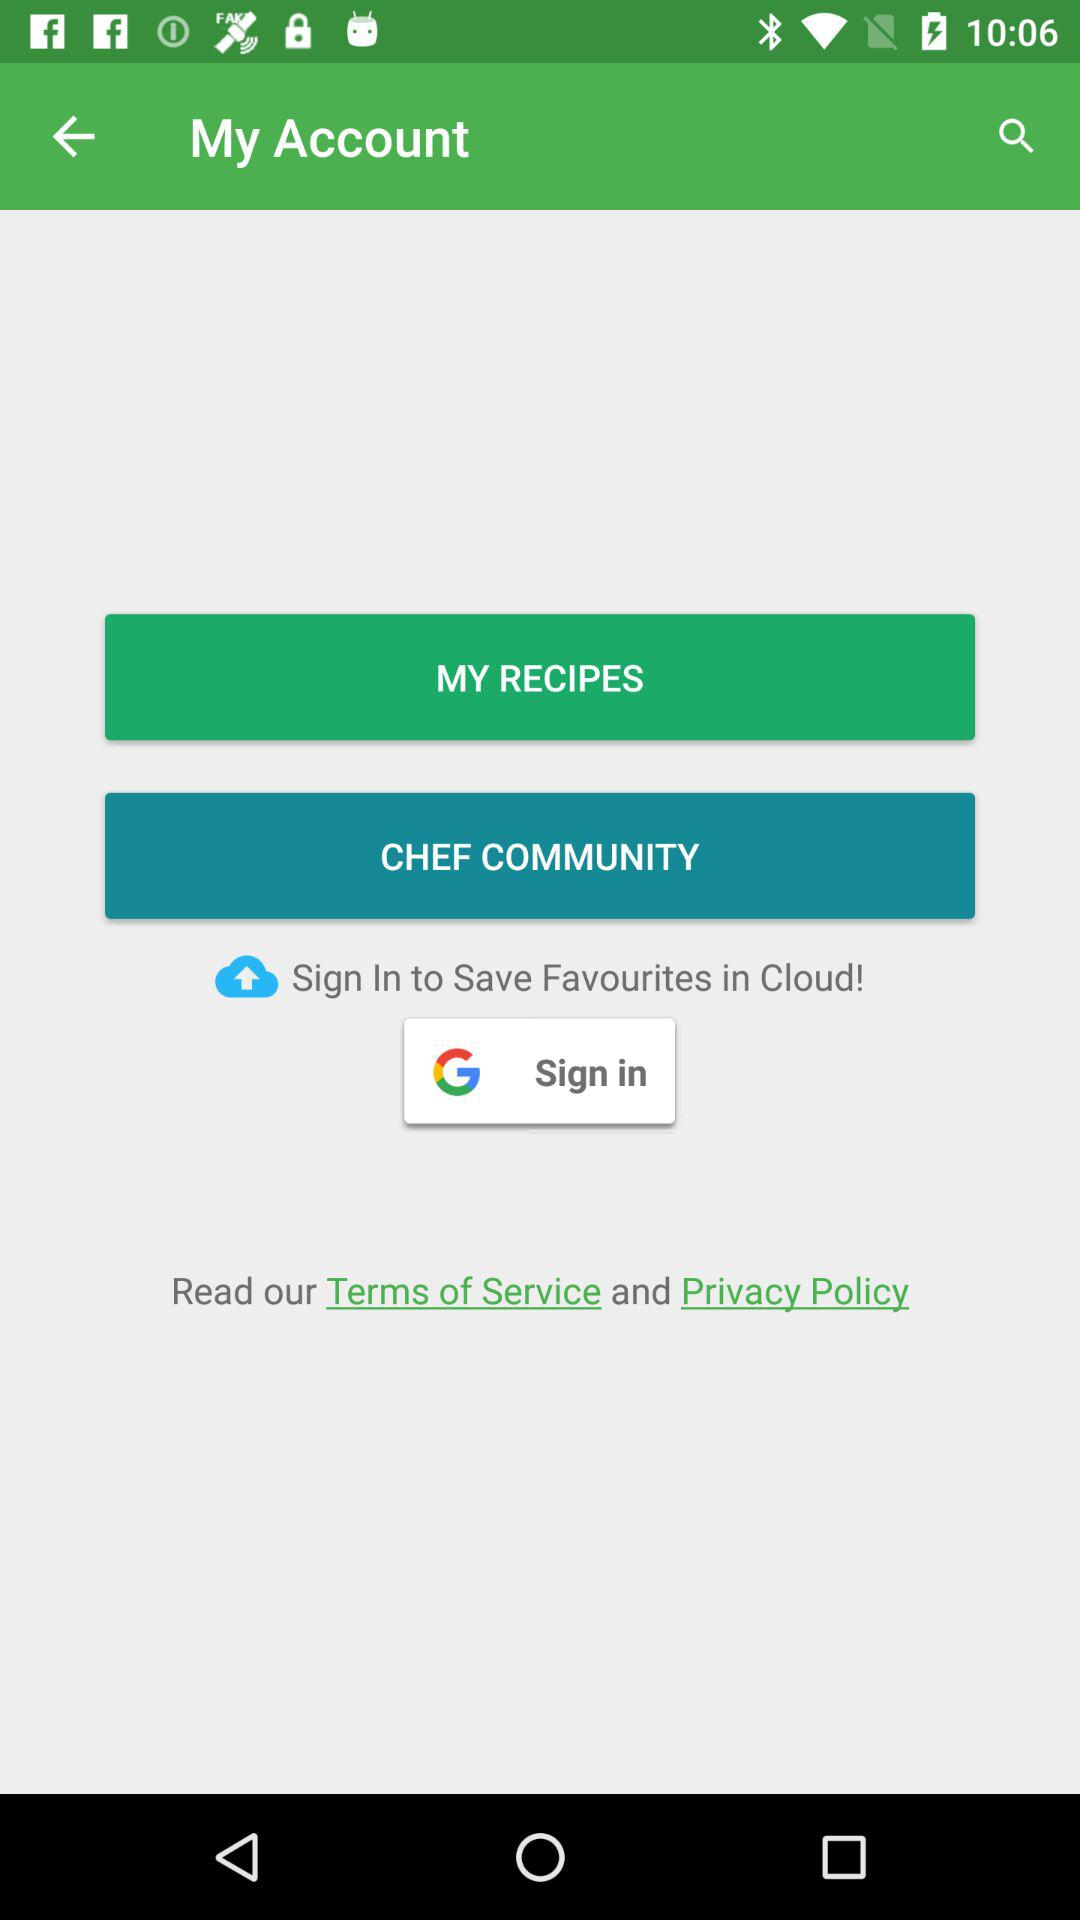Through which account can be signed in? You can sign in through "Google Cloud" and "Google". 